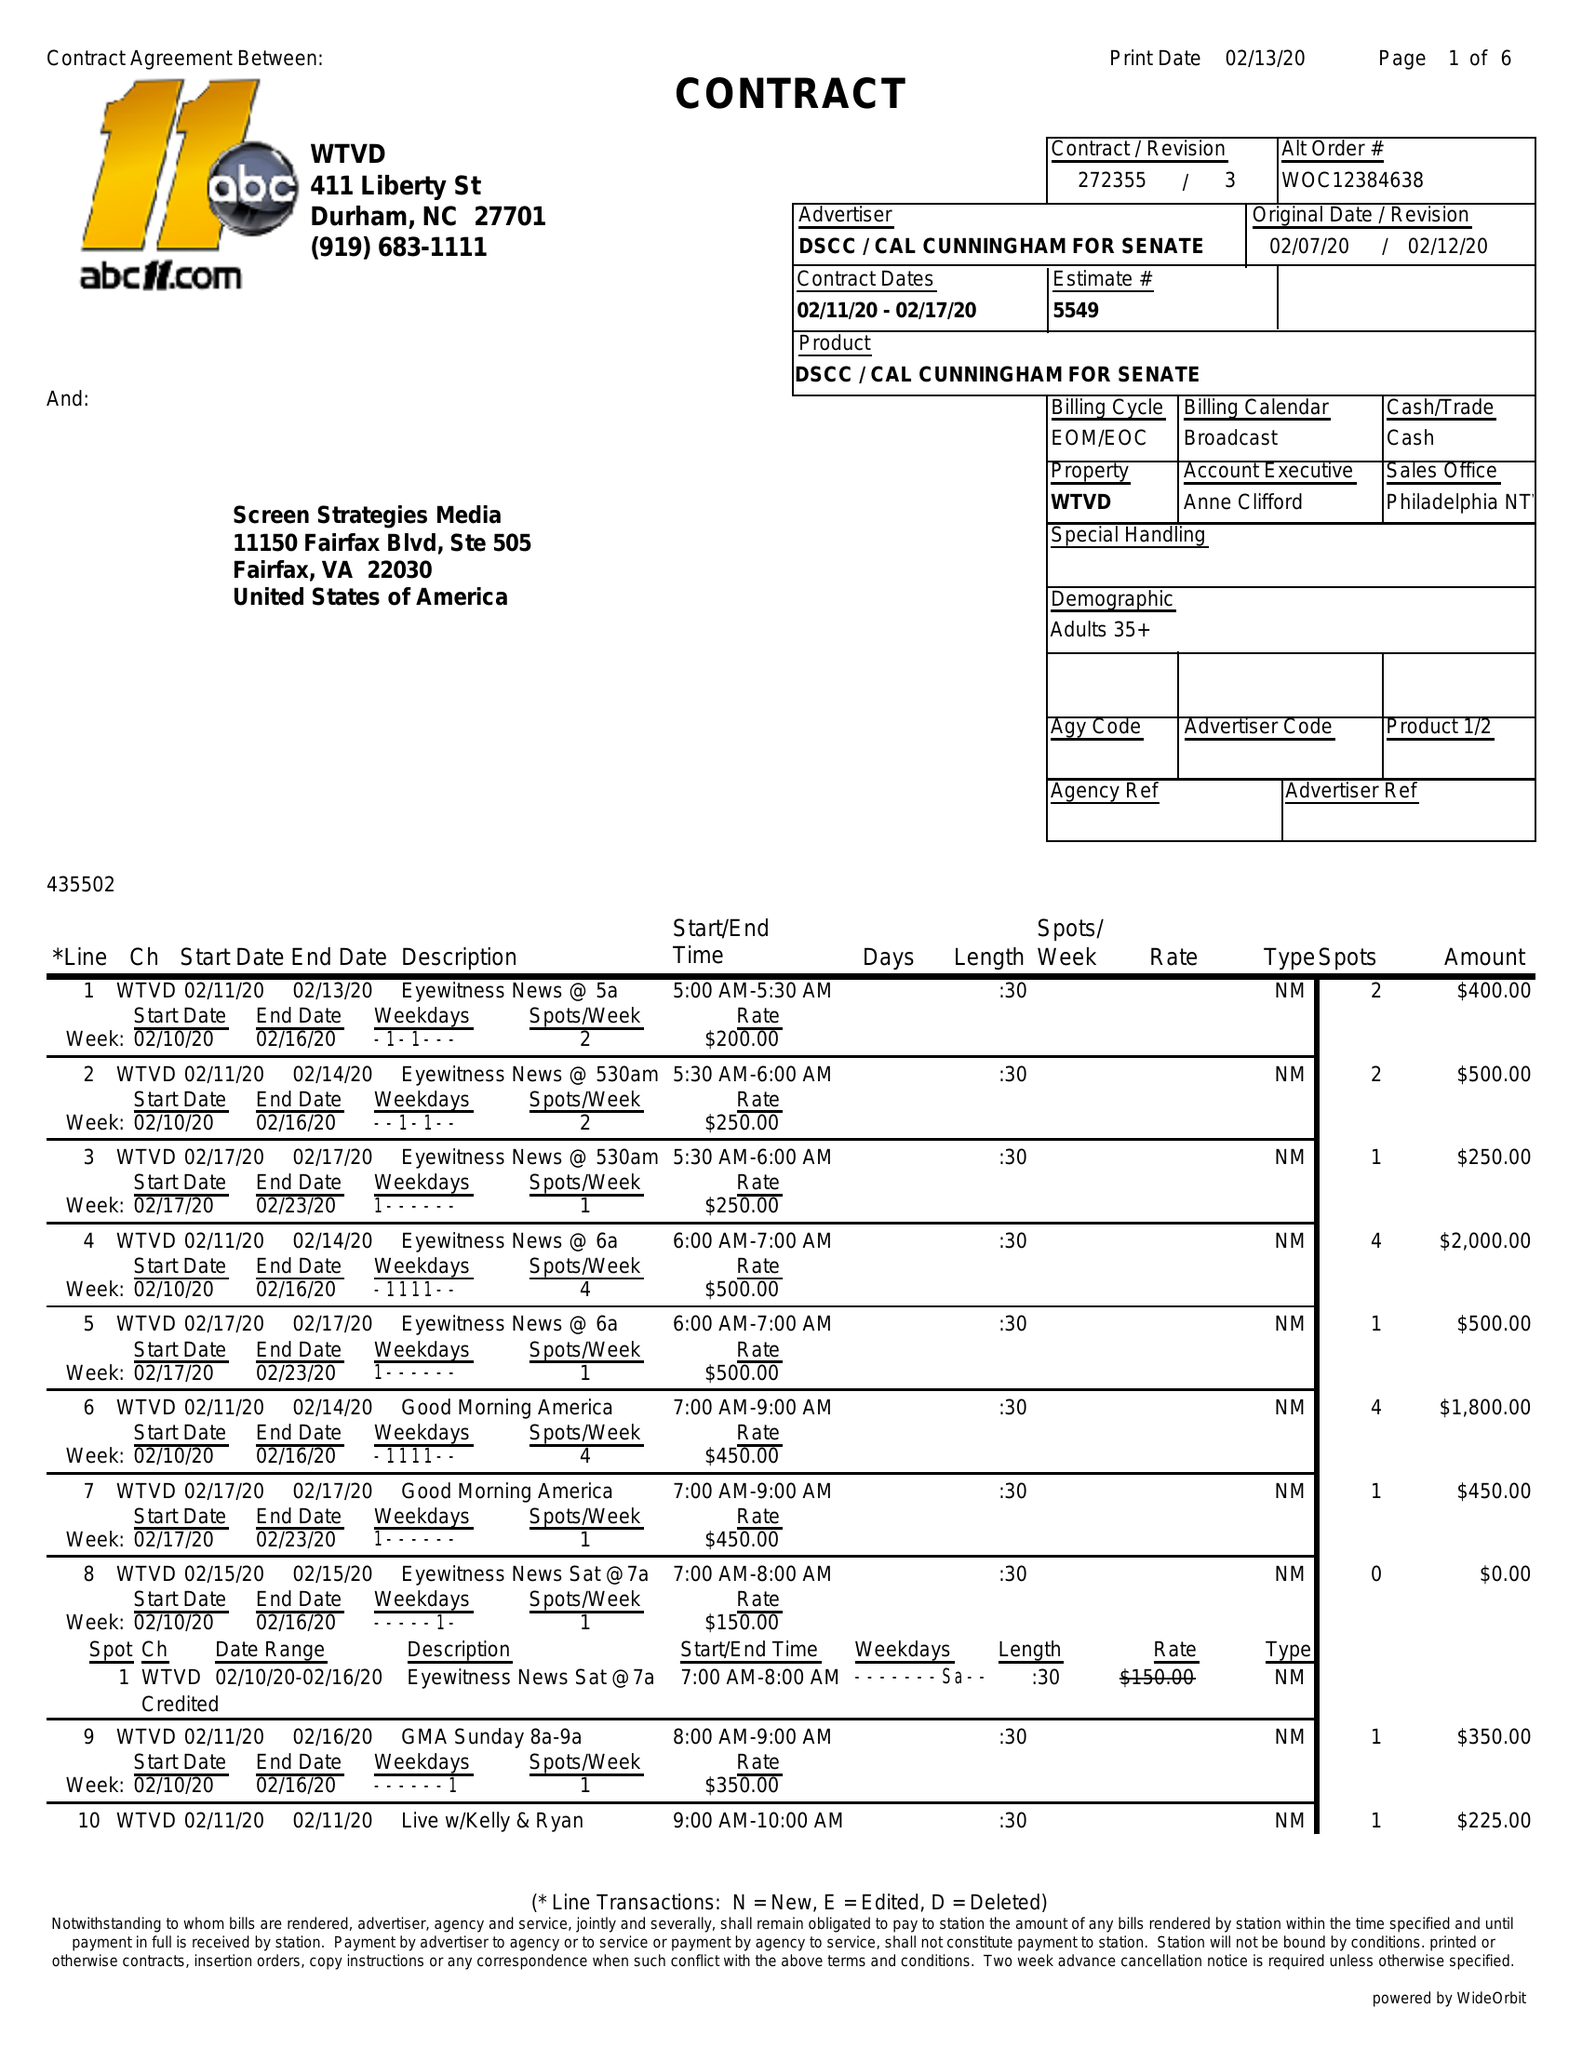What is the value for the flight_from?
Answer the question using a single word or phrase. 02/11/20 